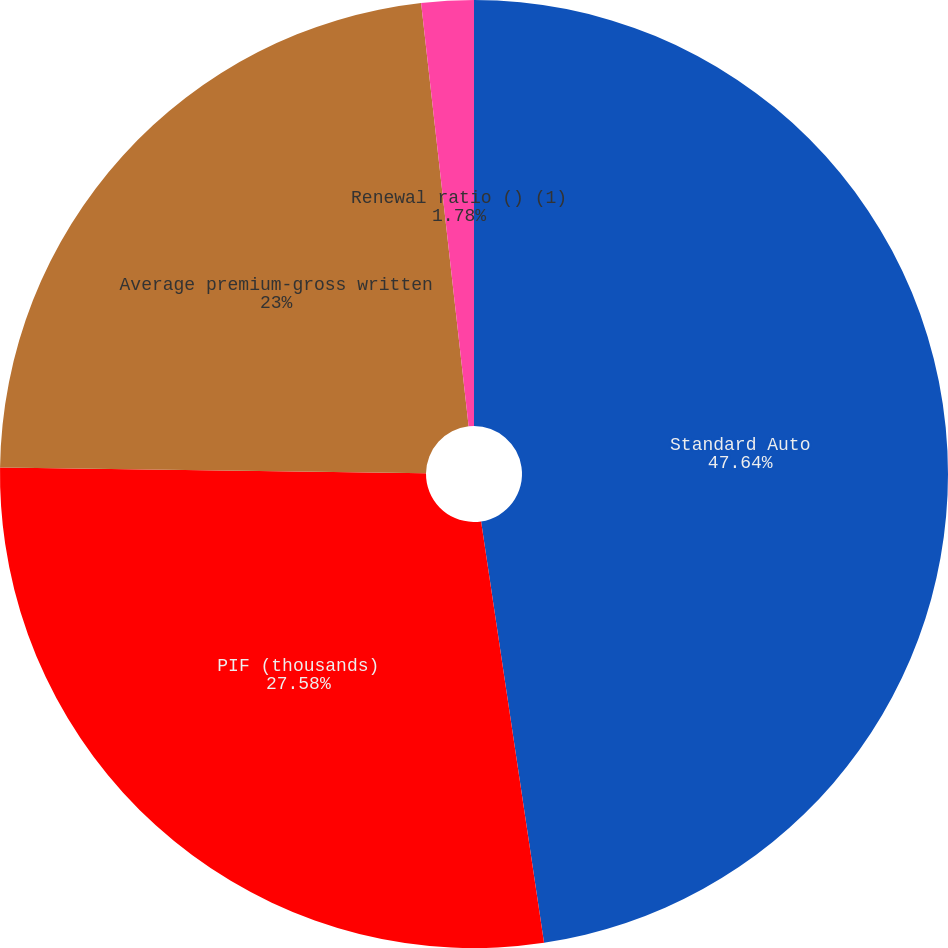Convert chart to OTSL. <chart><loc_0><loc_0><loc_500><loc_500><pie_chart><fcel>Standard Auto<fcel>PIF (thousands)<fcel>Average premium-gross written<fcel>Renewal ratio () (1)<nl><fcel>47.64%<fcel>27.58%<fcel>23.0%<fcel>1.78%<nl></chart> 